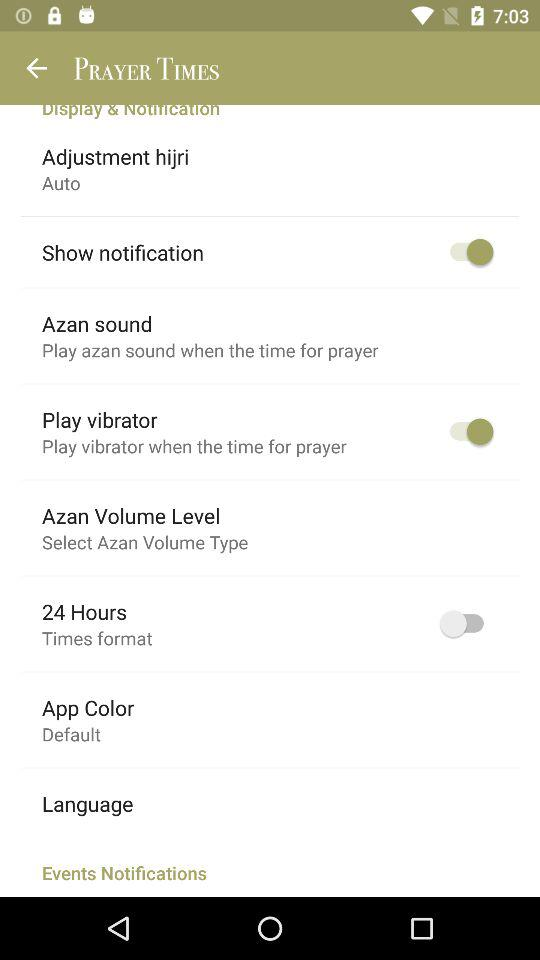What is the status of the "Show notification"? The status of the "Show notification" is "on". 